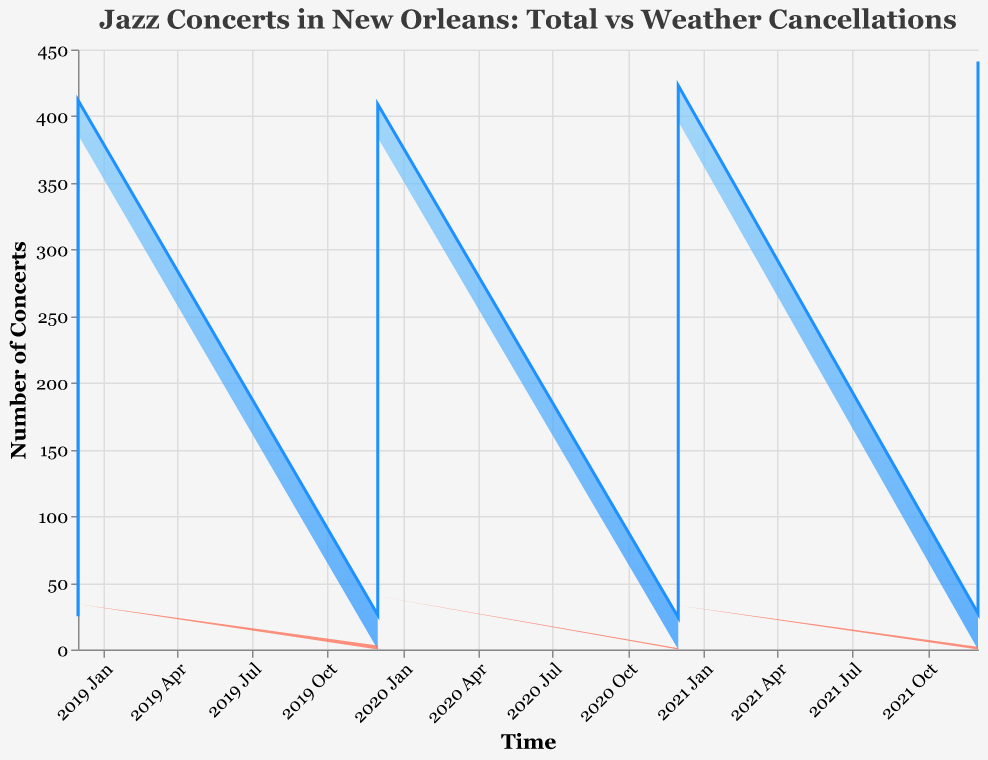What is the title of the chart? The title is located at the top of the chart and usually informs about the content being visualized.
Answer: Jazz Concerts in New Orleans: Total vs Weather Cancellations What does the y-axis represent? The y-axis typically denotes the numerical representation of the data, and in this chart, it shows the "Number of Concerts."
Answer: Number of Concerts What pattern do you observe for the total number of jazz concerts over the four years? The general pattern is a rise in the number of concerts from the beginning of each year with peaks around May and declines towards the end of the year each year.
Answer: Rise to peak in May, then decline Which month and year had the highest number of total jazz concerts? By observing the peaks of the blue area across different time points, we find May 2022 had the highest number of concerts.
Answer: May 2022 How many total jazz concerts were there in July 2020 and how many were canceled due to weather? For July 2020, we check the total (blue area) and the canceled (red area) figures, which are 41 and 7 respectively.
Answer: 41 total, 7 canceled What can you infer about the relationship between the months with the highest number of concerts and those with the highest cancellations? Months with the highest concerts often correspond to months with high cancellations, especially May, July, and August.
Answer: Higher concerts often correlate with higher cancellations Which month experienced the least number of cancellations across all the years? By identifying the months with minimal red area, December exhibits the least cancellations each year.
Answer: December Compare the number of concerts canceled due to weather in August 2019 with that in August 2021. Which month had more cancellations? By comparing the red areas for August 2019 (7) and August 2021 (7), it's clear both months had the same number of cancellations.
Answer: Both months had 7 cancellations What time of year tends to have the maximum cancellations due to weather? Observing months with larger red areas consistently, the summer months (July and August) have the most cancellations.
Answer: July and August Is there any month in 2021 where no concerts were canceled due to weather? Looking for months without any red area for 2021, April and December had zero cancellations.
Answer: April and December 